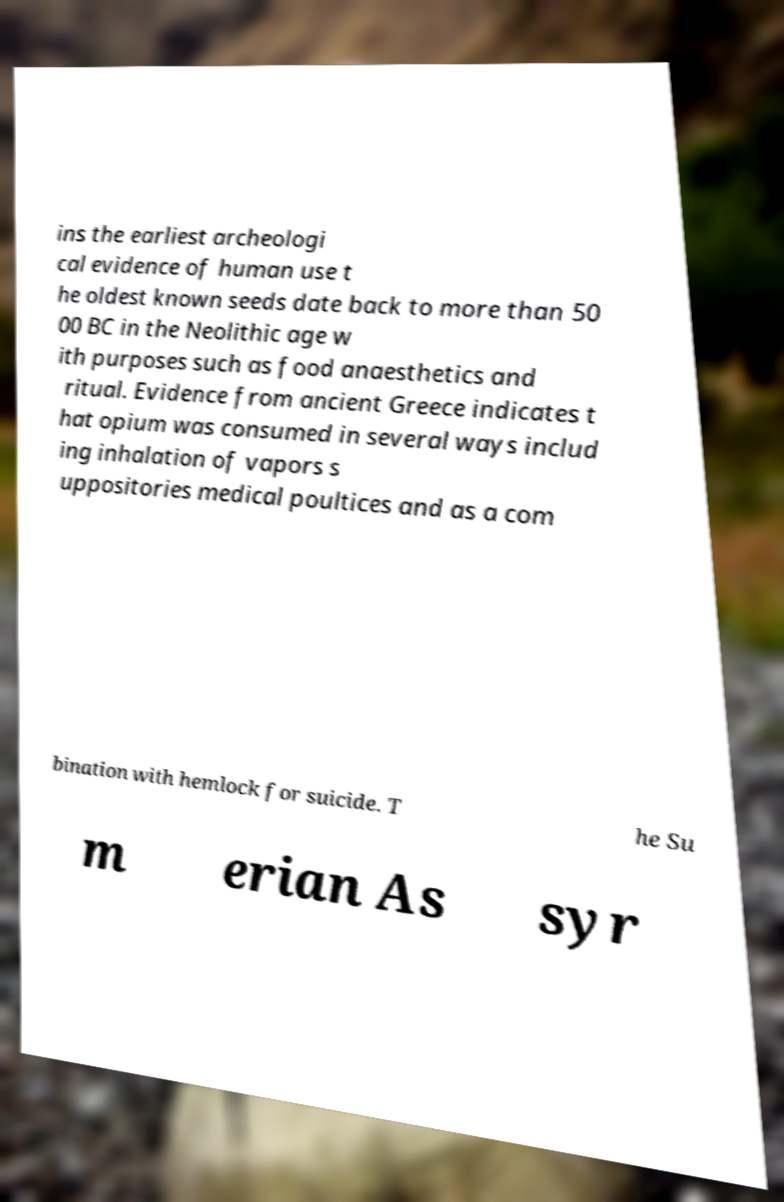Can you read and provide the text displayed in the image?This photo seems to have some interesting text. Can you extract and type it out for me? ins the earliest archeologi cal evidence of human use t he oldest known seeds date back to more than 50 00 BC in the Neolithic age w ith purposes such as food anaesthetics and ritual. Evidence from ancient Greece indicates t hat opium was consumed in several ways includ ing inhalation of vapors s uppositories medical poultices and as a com bination with hemlock for suicide. T he Su m erian As syr 